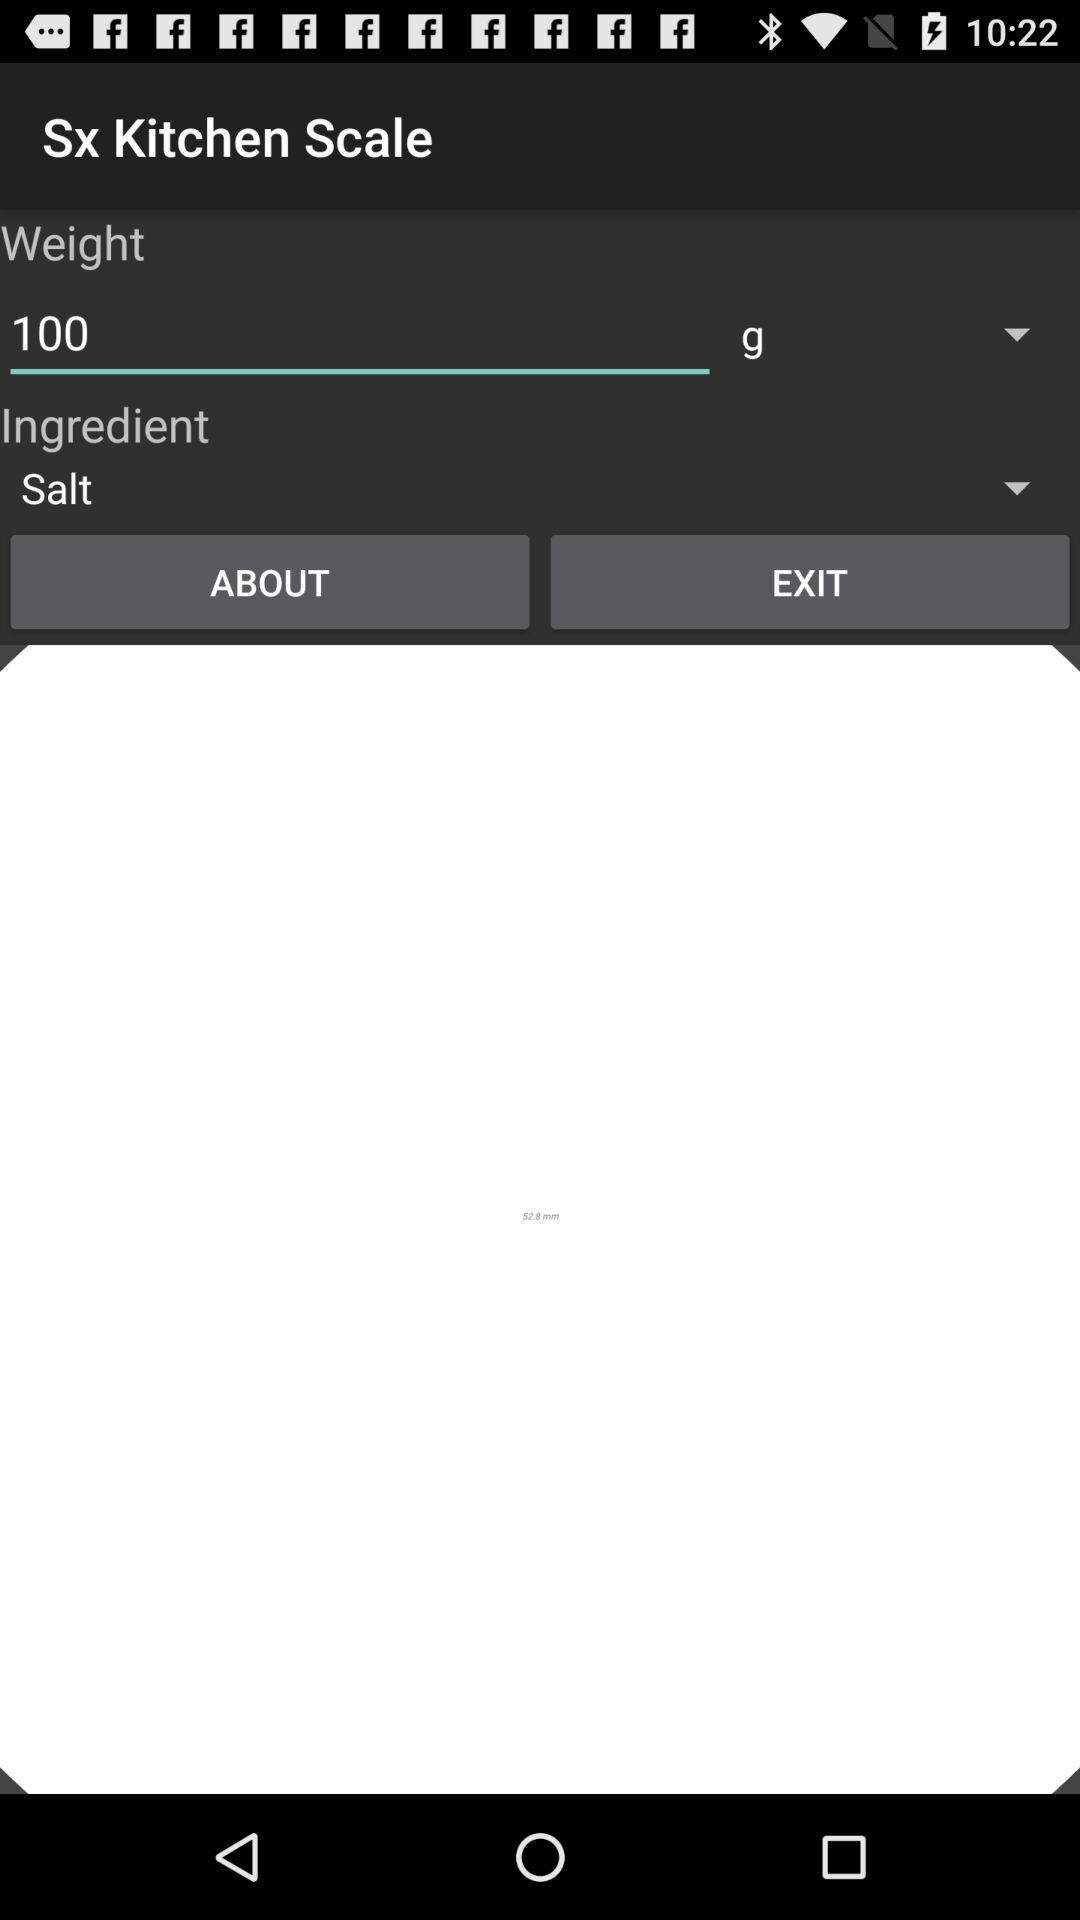What is the selected weight? The selected weight is 100 g. 